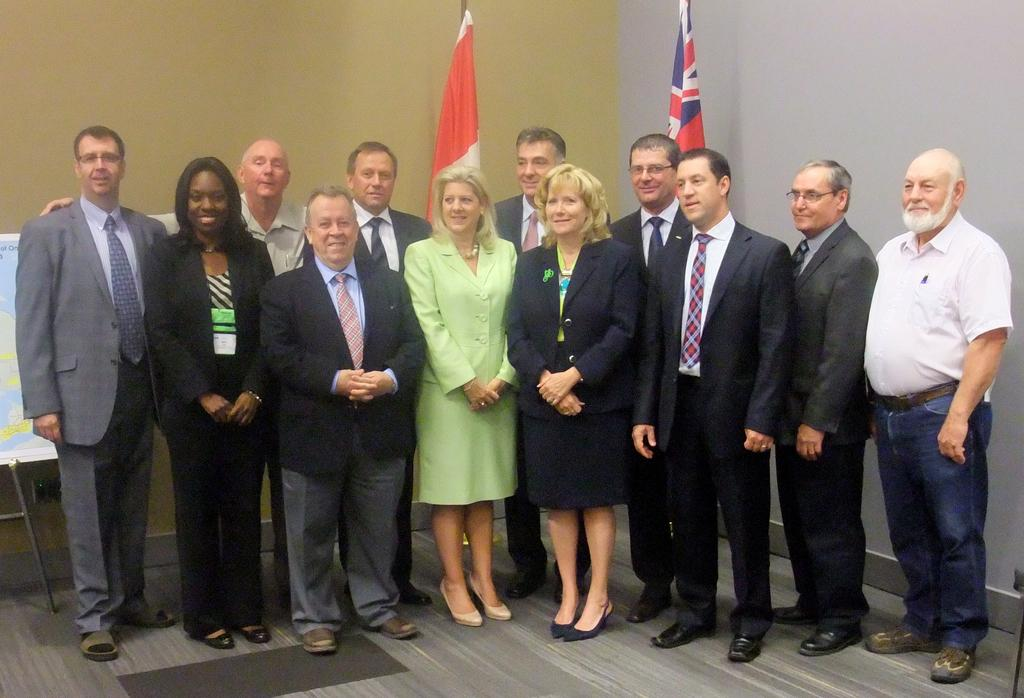What can be seen in the image? There are people standing in the image. Where are the people standing? The people are standing on the floor. What else is visible in the image besides the people? There are flags visible in the image. What is to the left of the image? There is a board to the left of the image. What is on the floor? There is a carpet on the floor. What is in the background of the image? There is a wall in the background of the image. Can you see a boat in the image? No, there is no boat present in the image. What type of boot is being worn by the people in the image? There is no mention of boots or footwear in the image, so it cannot be determined what type of boot the people might be wearing. 